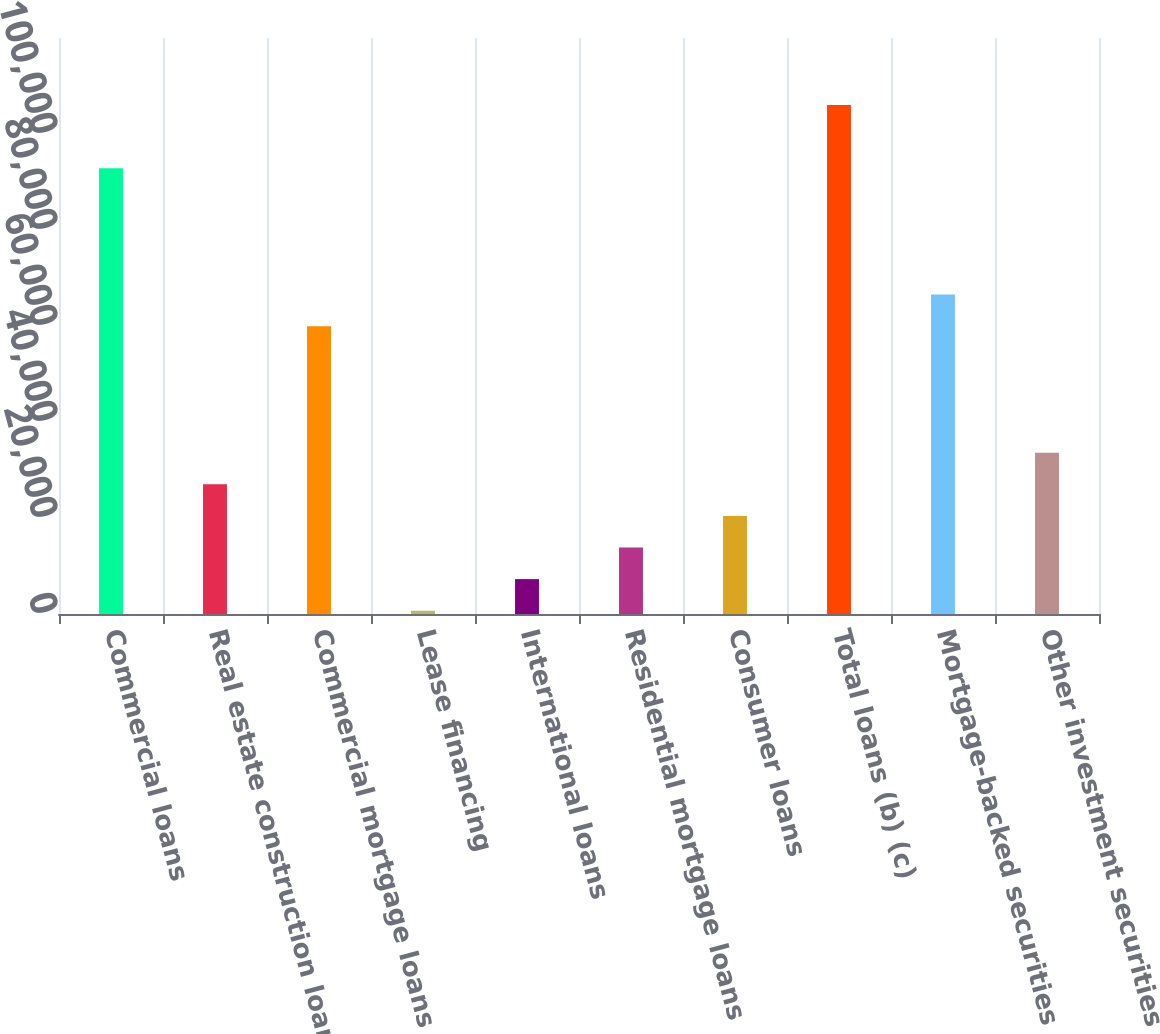<chart> <loc_0><loc_0><loc_500><loc_500><bar_chart><fcel>Commercial loans<fcel>Real estate construction loans<fcel>Commercial mortgage loans<fcel>Lease financing<fcel>International loans<fcel>Residential mortgage loans<fcel>Consumer loans<fcel>Total loans (b) (c)<fcel>Mortgage-backed securities<fcel>Other investment securities<nl><fcel>92889.4<fcel>27028.4<fcel>59958.9<fcel>684<fcel>7270.1<fcel>13856.2<fcel>20442.3<fcel>106062<fcel>66545<fcel>33614.5<nl></chart> 